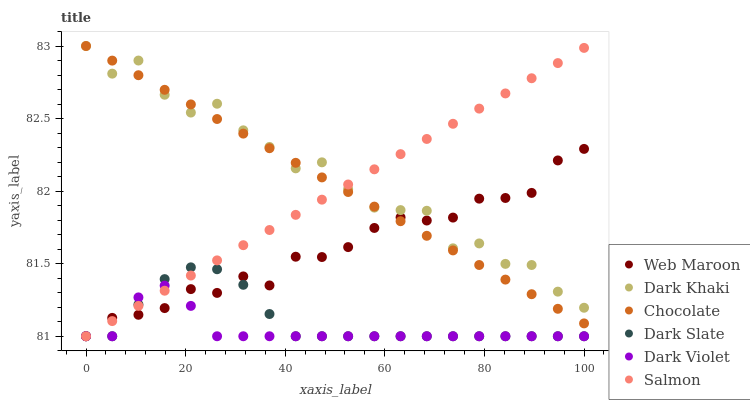Does Dark Violet have the minimum area under the curve?
Answer yes or no. Yes. Does Dark Khaki have the maximum area under the curve?
Answer yes or no. Yes. Does Salmon have the minimum area under the curve?
Answer yes or no. No. Does Salmon have the maximum area under the curve?
Answer yes or no. No. Is Salmon the smoothest?
Answer yes or no. Yes. Is Dark Khaki the roughest?
Answer yes or no. Yes. Is Dark Violet the smoothest?
Answer yes or no. No. Is Dark Violet the roughest?
Answer yes or no. No. Does Web Maroon have the lowest value?
Answer yes or no. Yes. Does Chocolate have the lowest value?
Answer yes or no. No. Does Dark Khaki have the highest value?
Answer yes or no. Yes. Does Salmon have the highest value?
Answer yes or no. No. Is Dark Violet less than Chocolate?
Answer yes or no. Yes. Is Chocolate greater than Dark Slate?
Answer yes or no. Yes. Does Salmon intersect Dark Slate?
Answer yes or no. Yes. Is Salmon less than Dark Slate?
Answer yes or no. No. Is Salmon greater than Dark Slate?
Answer yes or no. No. Does Dark Violet intersect Chocolate?
Answer yes or no. No. 